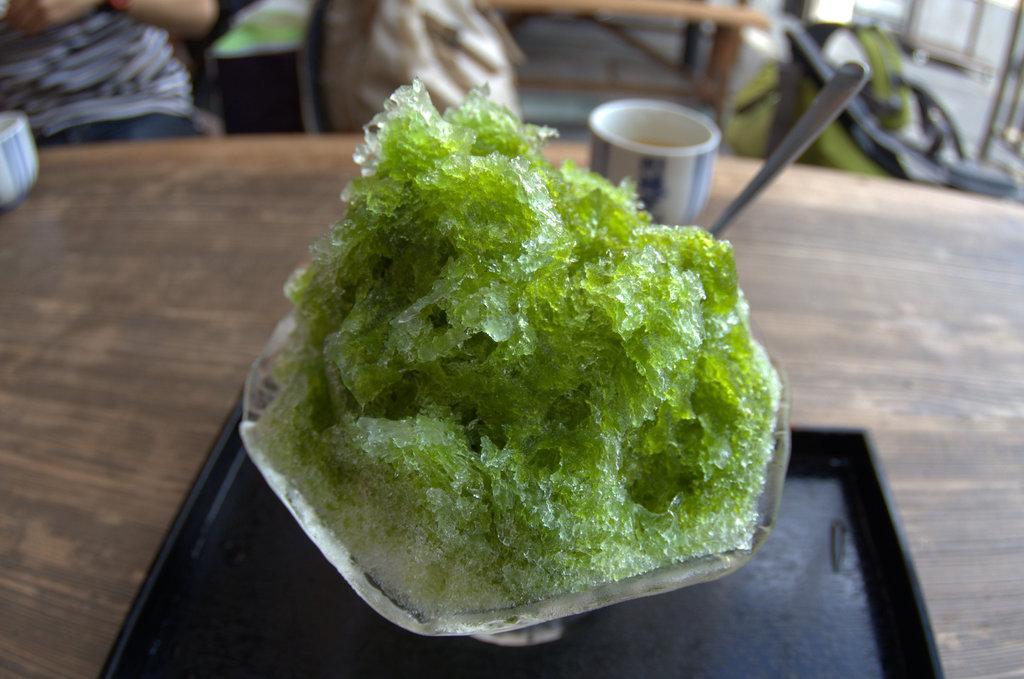Can you describe this image briefly? In the image,there is some green color dish prepared with ice is served in a cup and it is placed on a wooden table and the background is blur. 